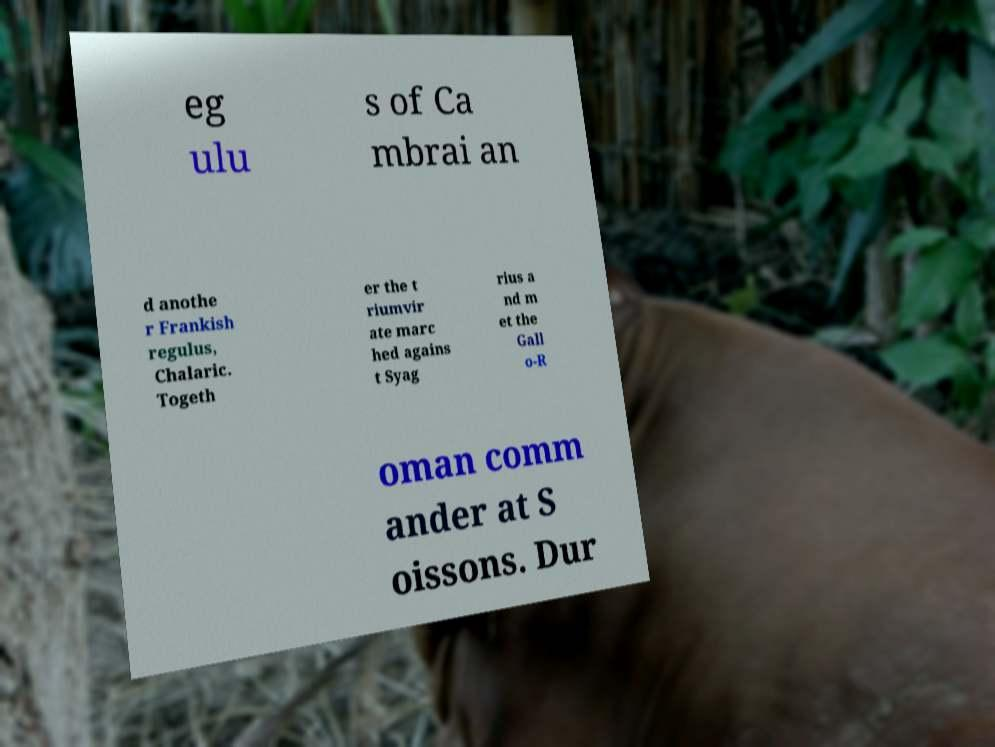I need the written content from this picture converted into text. Can you do that? eg ulu s of Ca mbrai an d anothe r Frankish regulus, Chalaric. Togeth er the t riumvir ate marc hed agains t Syag rius a nd m et the Gall o-R oman comm ander at S oissons. Dur 